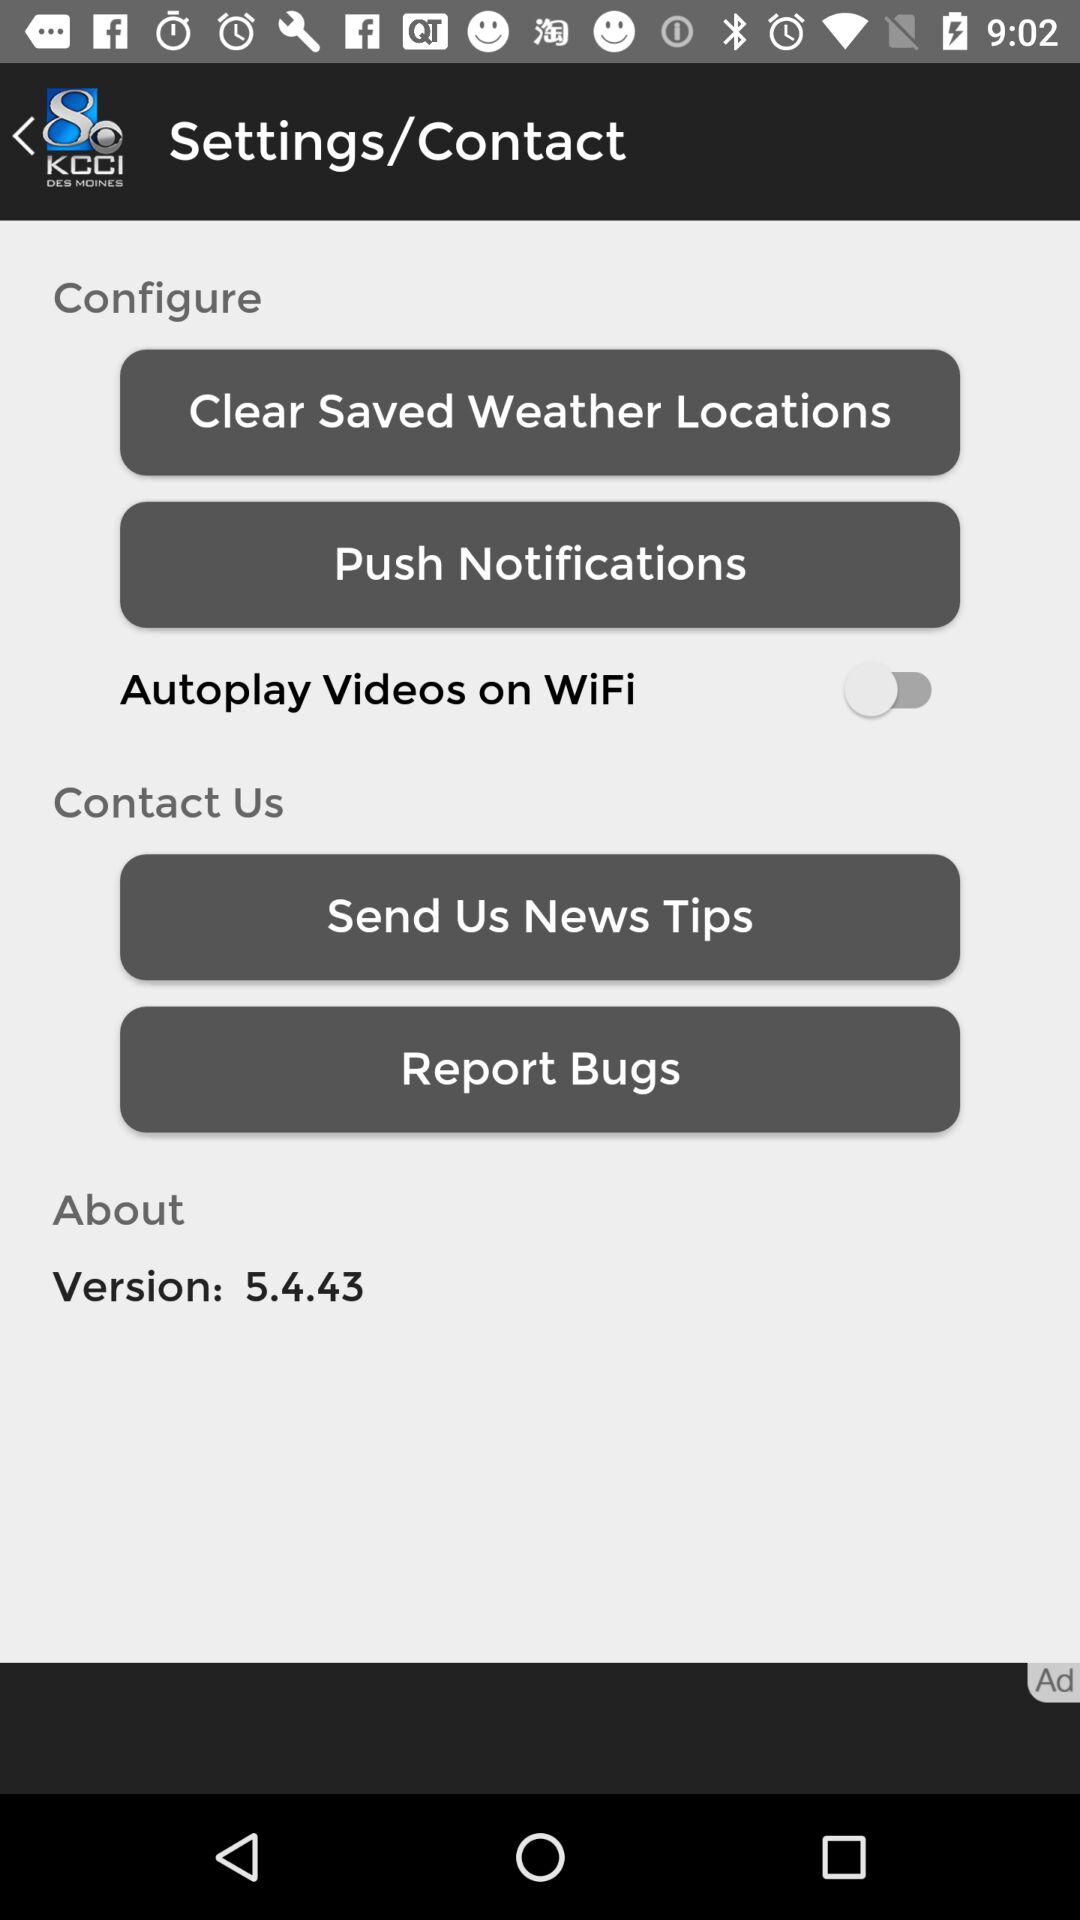What is the status of the "Autoplay Videos on WiFi" setting? The status of the "Autoplay Videos on WiFi" setting is "off". 